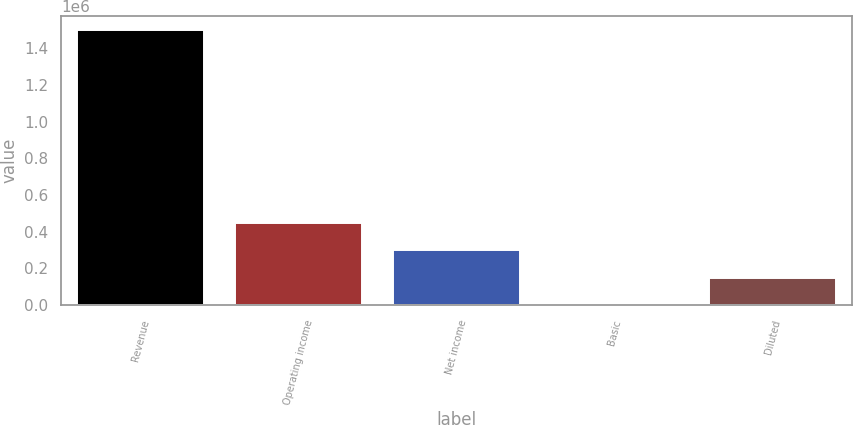<chart> <loc_0><loc_0><loc_500><loc_500><bar_chart><fcel>Revenue<fcel>Operating income<fcel>Net income<fcel>Basic<fcel>Diluted<nl><fcel>1.49908e+06<fcel>449723<fcel>299815<fcel>0.23<fcel>149908<nl></chart> 